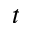Convert formula to latex. <formula><loc_0><loc_0><loc_500><loc_500>t</formula> 